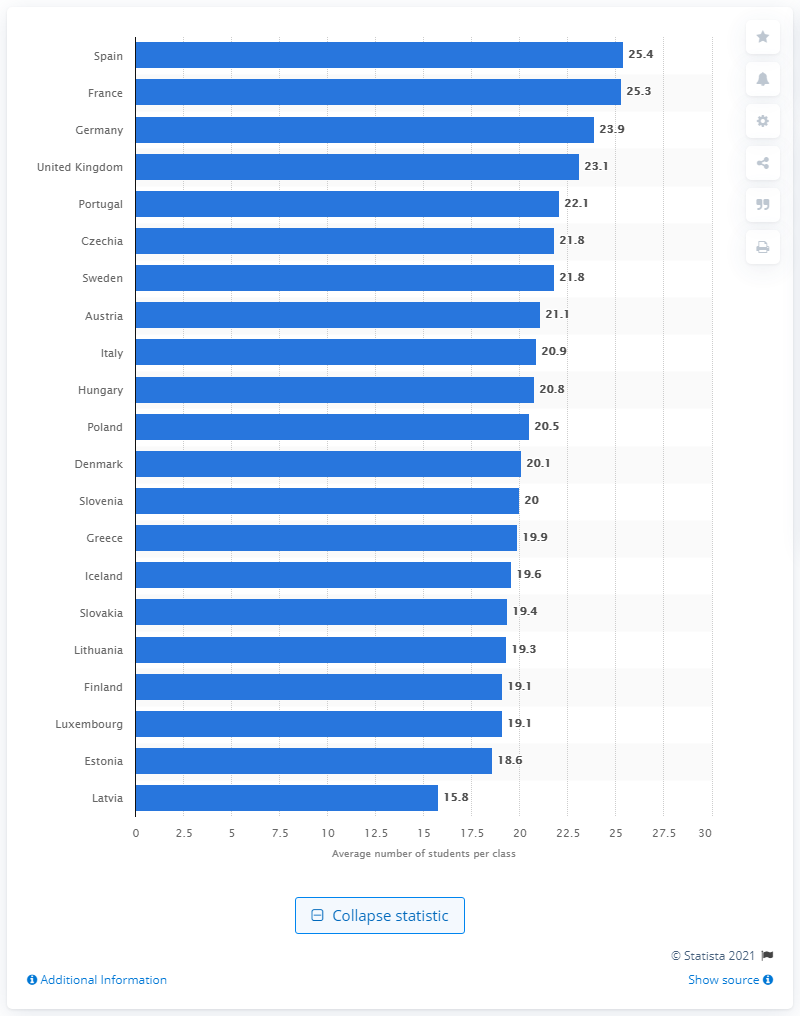Identify some key points in this picture. Spain had the highest number of students per class in Europe in 2018. In 2018, Latvia had the lowest average of students in secondary level classes. In 2018, the average number of students in a class in Spain was 25.4. In 2018, the average number of students per class in Latvia was 15.8. 